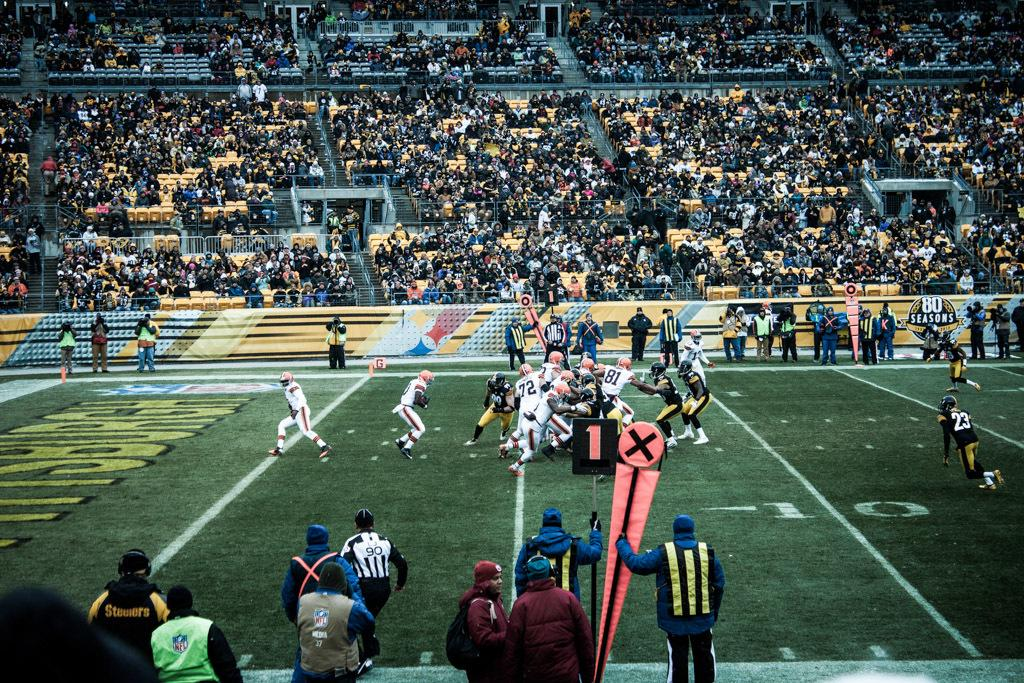<image>
Give a short and clear explanation of the subsequent image. A football game in progress with a sign on the stands that says 80 seasons. 